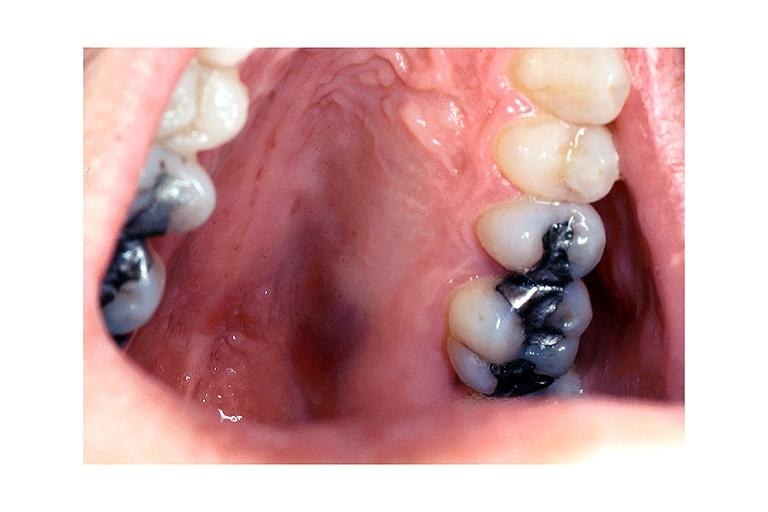s oral present?
Answer the question using a single word or phrase. Yes 